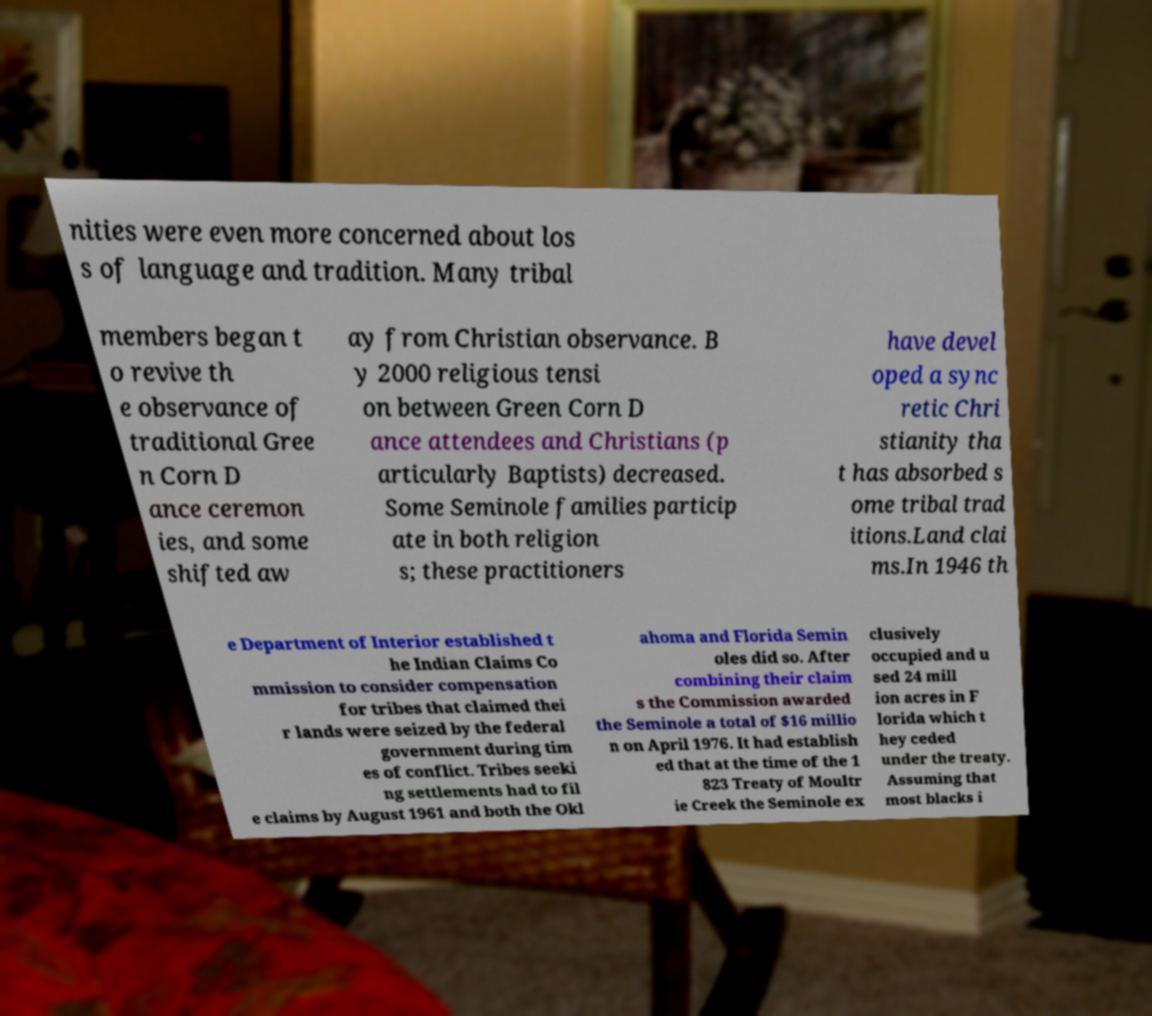Could you assist in decoding the text presented in this image and type it out clearly? nities were even more concerned about los s of language and tradition. Many tribal members began t o revive th e observance of traditional Gree n Corn D ance ceremon ies, and some shifted aw ay from Christian observance. B y 2000 religious tensi on between Green Corn D ance attendees and Christians (p articularly Baptists) decreased. Some Seminole families particip ate in both religion s; these practitioners have devel oped a sync retic Chri stianity tha t has absorbed s ome tribal trad itions.Land clai ms.In 1946 th e Department of Interior established t he Indian Claims Co mmission to consider compensation for tribes that claimed thei r lands were seized by the federal government during tim es of conflict. Tribes seeki ng settlements had to fil e claims by August 1961 and both the Okl ahoma and Florida Semin oles did so. After combining their claim s the Commission awarded the Seminole a total of $16 millio n on April 1976. It had establish ed that at the time of the 1 823 Treaty of Moultr ie Creek the Seminole ex clusively occupied and u sed 24 mill ion acres in F lorida which t hey ceded under the treaty. Assuming that most blacks i 